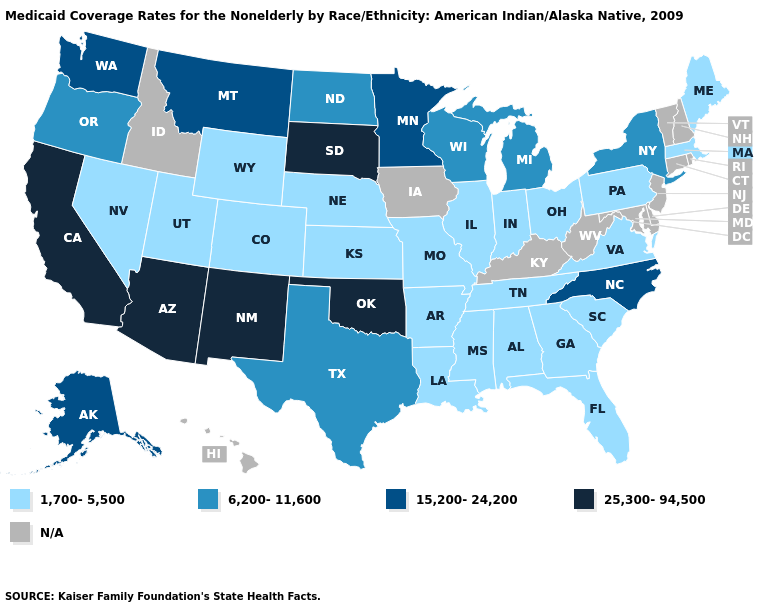What is the highest value in states that border Arizona?
Write a very short answer. 25,300-94,500. Among the states that border Kansas , which have the lowest value?
Short answer required. Colorado, Missouri, Nebraska. How many symbols are there in the legend?
Give a very brief answer. 5. What is the value of Massachusetts?
Short answer required. 1,700-5,500. What is the highest value in states that border New Hampshire?
Short answer required. 1,700-5,500. Name the states that have a value in the range 15,200-24,200?
Short answer required. Alaska, Minnesota, Montana, North Carolina, Washington. Name the states that have a value in the range N/A?
Be succinct. Connecticut, Delaware, Hawaii, Idaho, Iowa, Kentucky, Maryland, New Hampshire, New Jersey, Rhode Island, Vermont, West Virginia. Name the states that have a value in the range N/A?
Short answer required. Connecticut, Delaware, Hawaii, Idaho, Iowa, Kentucky, Maryland, New Hampshire, New Jersey, Rhode Island, Vermont, West Virginia. What is the value of Nevada?
Give a very brief answer. 1,700-5,500. What is the value of New York?
Give a very brief answer. 6,200-11,600. Name the states that have a value in the range N/A?
Concise answer only. Connecticut, Delaware, Hawaii, Idaho, Iowa, Kentucky, Maryland, New Hampshire, New Jersey, Rhode Island, Vermont, West Virginia. What is the value of California?
Short answer required. 25,300-94,500. Name the states that have a value in the range 15,200-24,200?
Short answer required. Alaska, Minnesota, Montana, North Carolina, Washington. 